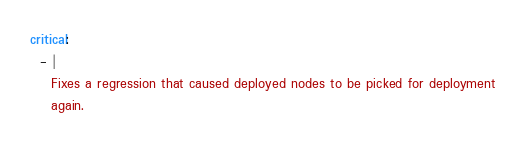<code> <loc_0><loc_0><loc_500><loc_500><_YAML_>critical:
  - |
    Fixes a regression that caused deployed nodes to be picked for deployment
    again.
</code> 